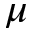<formula> <loc_0><loc_0><loc_500><loc_500>\mu</formula> 